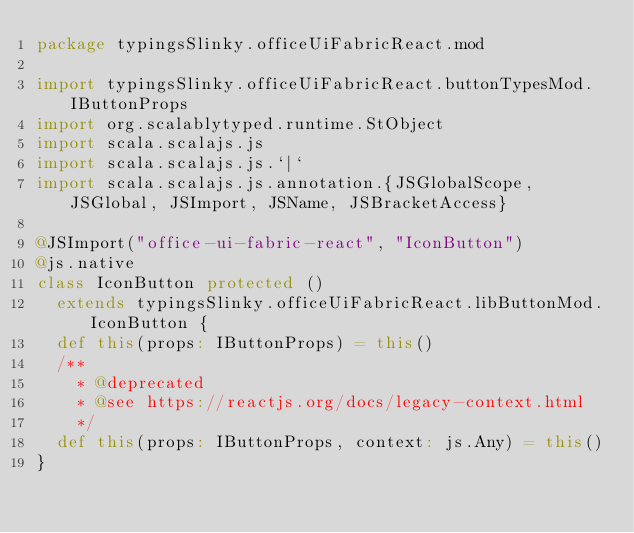<code> <loc_0><loc_0><loc_500><loc_500><_Scala_>package typingsSlinky.officeUiFabricReact.mod

import typingsSlinky.officeUiFabricReact.buttonTypesMod.IButtonProps
import org.scalablytyped.runtime.StObject
import scala.scalajs.js
import scala.scalajs.js.`|`
import scala.scalajs.js.annotation.{JSGlobalScope, JSGlobal, JSImport, JSName, JSBracketAccess}

@JSImport("office-ui-fabric-react", "IconButton")
@js.native
class IconButton protected ()
  extends typingsSlinky.officeUiFabricReact.libButtonMod.IconButton {
  def this(props: IButtonProps) = this()
  /**
    * @deprecated
    * @see https://reactjs.org/docs/legacy-context.html
    */
  def this(props: IButtonProps, context: js.Any) = this()
}
</code> 